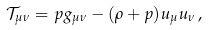Convert formula to latex. <formula><loc_0><loc_0><loc_500><loc_500>\mathcal { T } _ { \mu \nu } = p g _ { \mu \nu } - ( \rho + p ) u _ { \mu } u _ { \nu } \, ,</formula> 